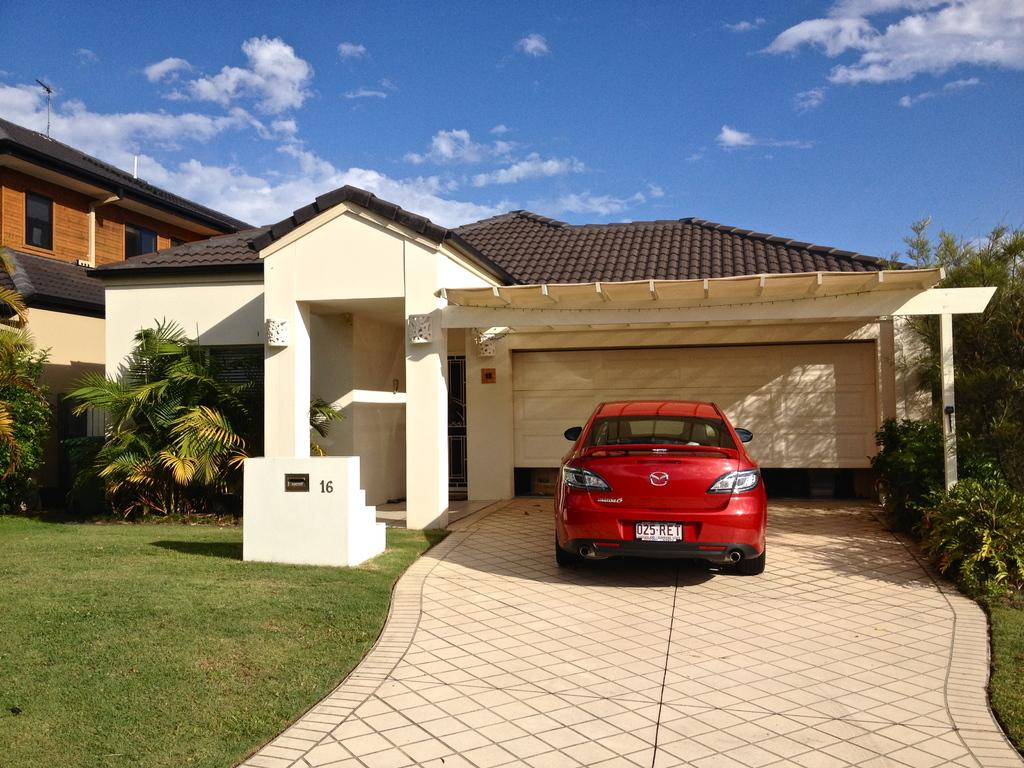What is on the ground in the image? There is a car on the ground in the image. What type of structures can be seen in the image? There are houses in the image. What type of vegetation is present in the image? There are trees and grass in the image. What can be seen in the background of the image? The sky is visible in the background of the image. Where is the fireman working in the image? There is no fireman present in the image. What type of food is being prepared in the garden in the image? There is no food or garden present in the image. 